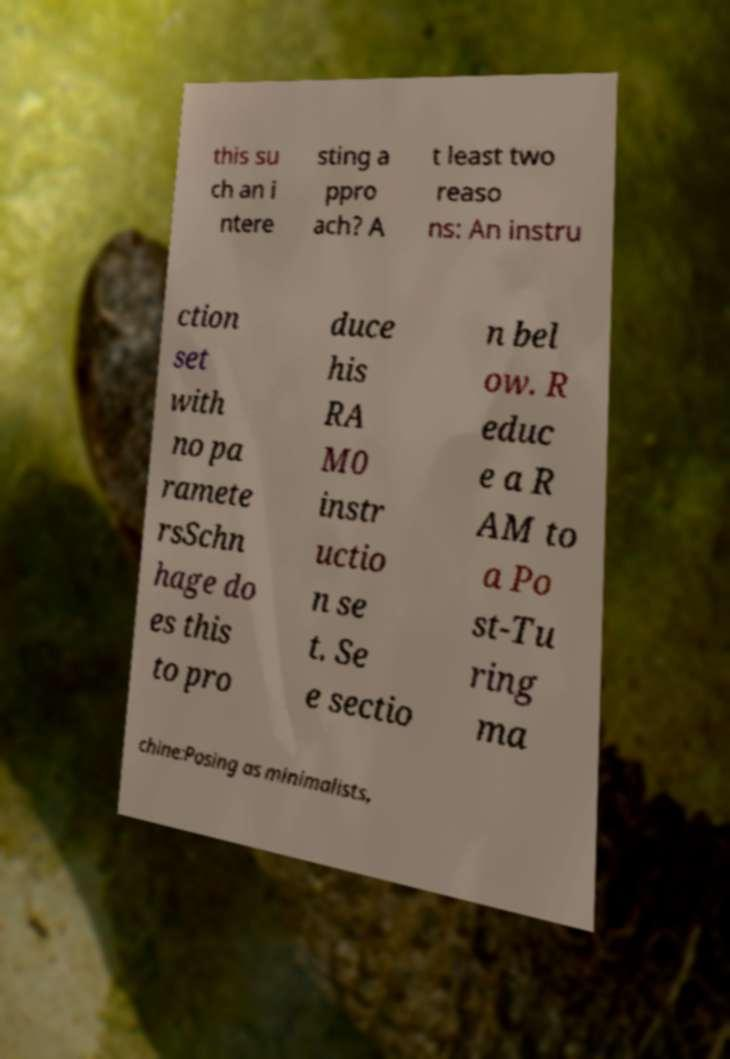There's text embedded in this image that I need extracted. Can you transcribe it verbatim? this su ch an i ntere sting a ppro ach? A t least two reaso ns: An instru ction set with no pa ramete rsSchn hage do es this to pro duce his RA M0 instr uctio n se t. Se e sectio n bel ow. R educ e a R AM to a Po st-Tu ring ma chine:Posing as minimalists, 